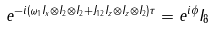<formula> <loc_0><loc_0><loc_500><loc_500>e ^ { - i ( \omega _ { 1 } I _ { x } \otimes I _ { 2 } \otimes I _ { 2 } + J _ { 1 2 } I _ { z } \otimes I _ { z } \otimes I _ { 2 } ) \tau } = e ^ { i \phi } I _ { 8 }</formula> 